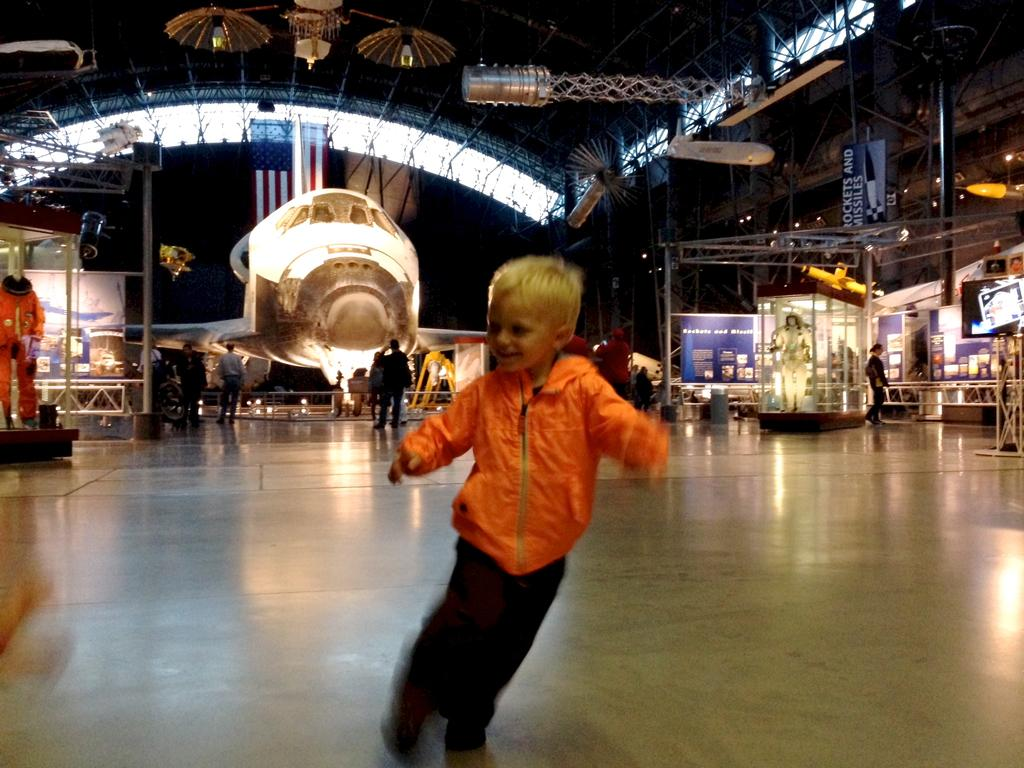What type of building is shown in the image? There is a mall in the image. Can you describe the people in the image? There are people in the image. What can be seen illuminating the scene in the image? A: There are lights in the image. How many geese are visible in the image? There are no geese present in the image. What type of connection can be seen between the people in the image? The image does not show any specific connections between the people; they are simply present in the scene. 